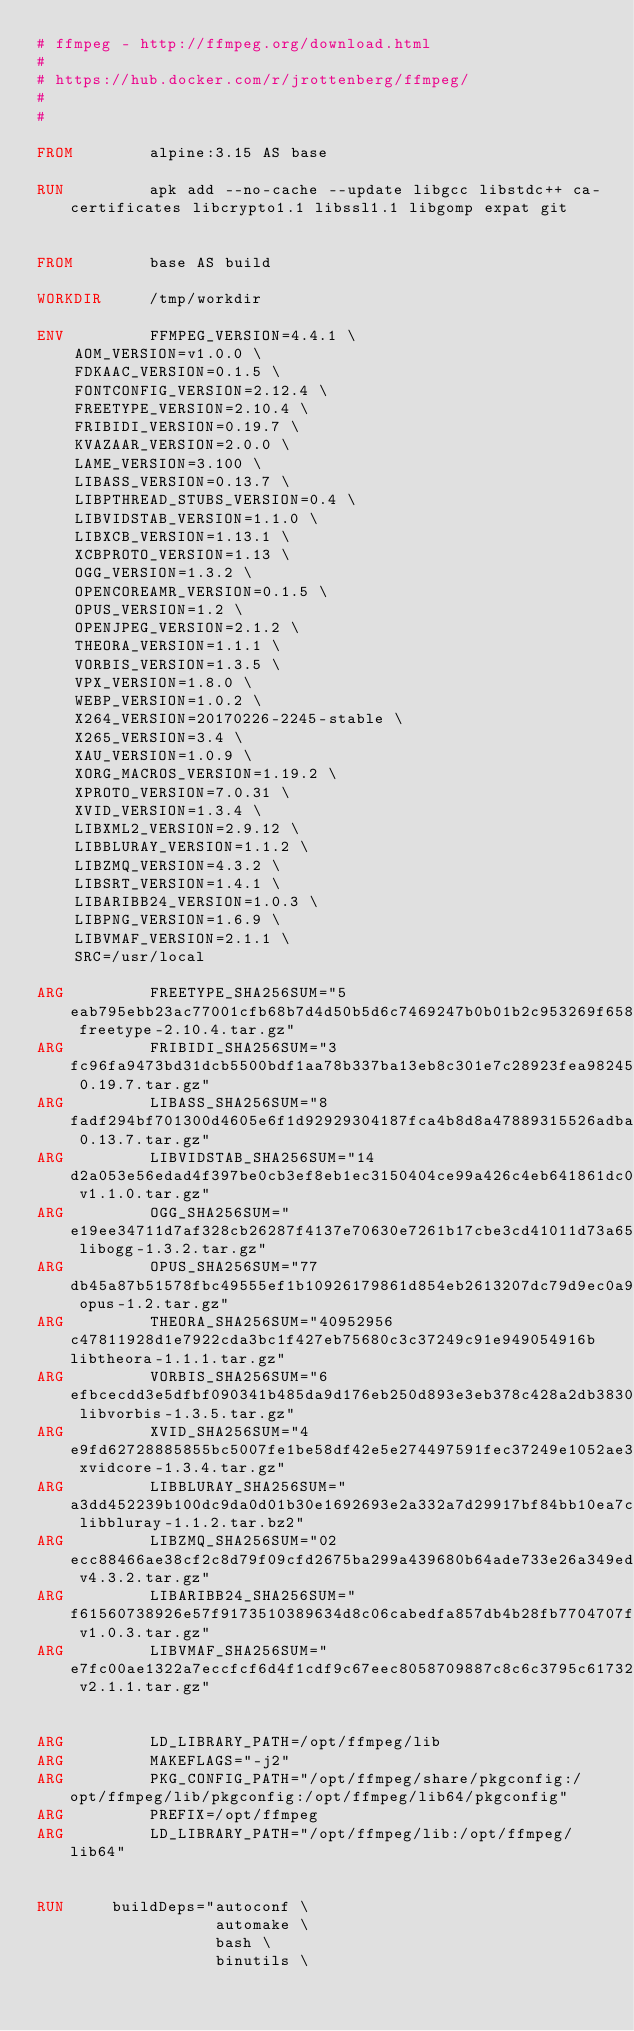Convert code to text. <code><loc_0><loc_0><loc_500><loc_500><_Dockerfile_># ffmpeg - http://ffmpeg.org/download.html
#
# https://hub.docker.com/r/jrottenberg/ffmpeg/
#
#

FROM        alpine:3.15 AS base

RUN         apk add --no-cache --update libgcc libstdc++ ca-certificates libcrypto1.1 libssl1.1 libgomp expat git


FROM        base AS build

WORKDIR     /tmp/workdir

ENV         FFMPEG_VERSION=4.4.1 \
    AOM_VERSION=v1.0.0 \
    FDKAAC_VERSION=0.1.5 \
    FONTCONFIG_VERSION=2.12.4 \
    FREETYPE_VERSION=2.10.4 \
    FRIBIDI_VERSION=0.19.7 \
    KVAZAAR_VERSION=2.0.0 \
    LAME_VERSION=3.100 \
    LIBASS_VERSION=0.13.7 \
    LIBPTHREAD_STUBS_VERSION=0.4 \
    LIBVIDSTAB_VERSION=1.1.0 \
    LIBXCB_VERSION=1.13.1 \
    XCBPROTO_VERSION=1.13 \
    OGG_VERSION=1.3.2 \
    OPENCOREAMR_VERSION=0.1.5 \
    OPUS_VERSION=1.2 \
    OPENJPEG_VERSION=2.1.2 \
    THEORA_VERSION=1.1.1 \
    VORBIS_VERSION=1.3.5 \
    VPX_VERSION=1.8.0 \
    WEBP_VERSION=1.0.2 \
    X264_VERSION=20170226-2245-stable \
    X265_VERSION=3.4 \
    XAU_VERSION=1.0.9 \
    XORG_MACROS_VERSION=1.19.2 \
    XPROTO_VERSION=7.0.31 \
    XVID_VERSION=1.3.4 \
    LIBXML2_VERSION=2.9.12 \
    LIBBLURAY_VERSION=1.1.2 \
    LIBZMQ_VERSION=4.3.2 \
    LIBSRT_VERSION=1.4.1 \
    LIBARIBB24_VERSION=1.0.3 \
    LIBPNG_VERSION=1.6.9 \
    LIBVMAF_VERSION=2.1.1 \
    SRC=/usr/local

ARG         FREETYPE_SHA256SUM="5eab795ebb23ac77001cfb68b7d4d50b5d6c7469247b0b01b2c953269f658dac freetype-2.10.4.tar.gz"
ARG         FRIBIDI_SHA256SUM="3fc96fa9473bd31dcb5500bdf1aa78b337ba13eb8c301e7c28923fea982453a8 0.19.7.tar.gz"
ARG         LIBASS_SHA256SUM="8fadf294bf701300d4605e6f1d92929304187fca4b8d8a47889315526adbafd7 0.13.7.tar.gz"
ARG         LIBVIDSTAB_SHA256SUM="14d2a053e56edad4f397be0cb3ef8eb1ec3150404ce99a426c4eb641861dc0bb v1.1.0.tar.gz"
ARG         OGG_SHA256SUM="e19ee34711d7af328cb26287f4137e70630e7261b17cbe3cd41011d73a654692 libogg-1.3.2.tar.gz"
ARG         OPUS_SHA256SUM="77db45a87b51578fbc49555ef1b10926179861d854eb2613207dc79d9ec0a9a9 opus-1.2.tar.gz"
ARG         THEORA_SHA256SUM="40952956c47811928d1e7922cda3bc1f427eb75680c3c37249c91e949054916b libtheora-1.1.1.tar.gz"
ARG         VORBIS_SHA256SUM="6efbcecdd3e5dfbf090341b485da9d176eb250d893e3eb378c428a2db38301ce libvorbis-1.3.5.tar.gz"
ARG         XVID_SHA256SUM="4e9fd62728885855bc5007fe1be58df42e5e274497591fec37249e1052ae316f xvidcore-1.3.4.tar.gz"
ARG         LIBBLURAY_SHA256SUM="a3dd452239b100dc9da0d01b30e1692693e2a332a7d29917bf84bb10ea7c0b42 libbluray-1.1.2.tar.bz2"
ARG         LIBZMQ_SHA256SUM="02ecc88466ae38cf2c8d79f09cfd2675ba299a439680b64ade733e26a349edeb v4.3.2.tar.gz"
ARG         LIBARIBB24_SHA256SUM="f61560738926e57f9173510389634d8c06cabedfa857db4b28fb7704707ff128 v1.0.3.tar.gz"
ARG         LIBVMAF_SHA256SUM="e7fc00ae1322a7eccfcf6d4f1cdf9c67eec8058709887c8c6c3795c617326f77 v2.1.1.tar.gz"


ARG         LD_LIBRARY_PATH=/opt/ffmpeg/lib
ARG         MAKEFLAGS="-j2"
ARG         PKG_CONFIG_PATH="/opt/ffmpeg/share/pkgconfig:/opt/ffmpeg/lib/pkgconfig:/opt/ffmpeg/lib64/pkgconfig"
ARG         PREFIX=/opt/ffmpeg
ARG         LD_LIBRARY_PATH="/opt/ffmpeg/lib:/opt/ffmpeg/lib64"


RUN     buildDeps="autoconf \
                   automake \
                   bash \
                   binutils \</code> 